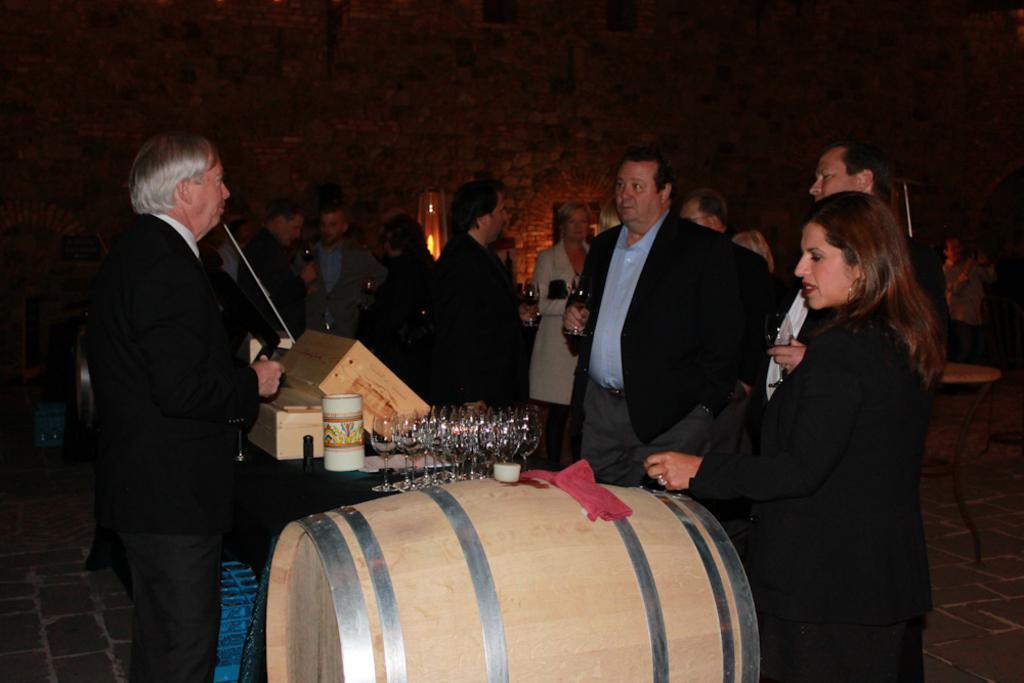Please provide a concise description of this image. In this picture I can observe some people standing on the floor. There are men and women in this picture. In the bottom of the picture I can observe barrel. In the middle of the picture I can observe some glasses placed on the table. In the background I can observe wall. 